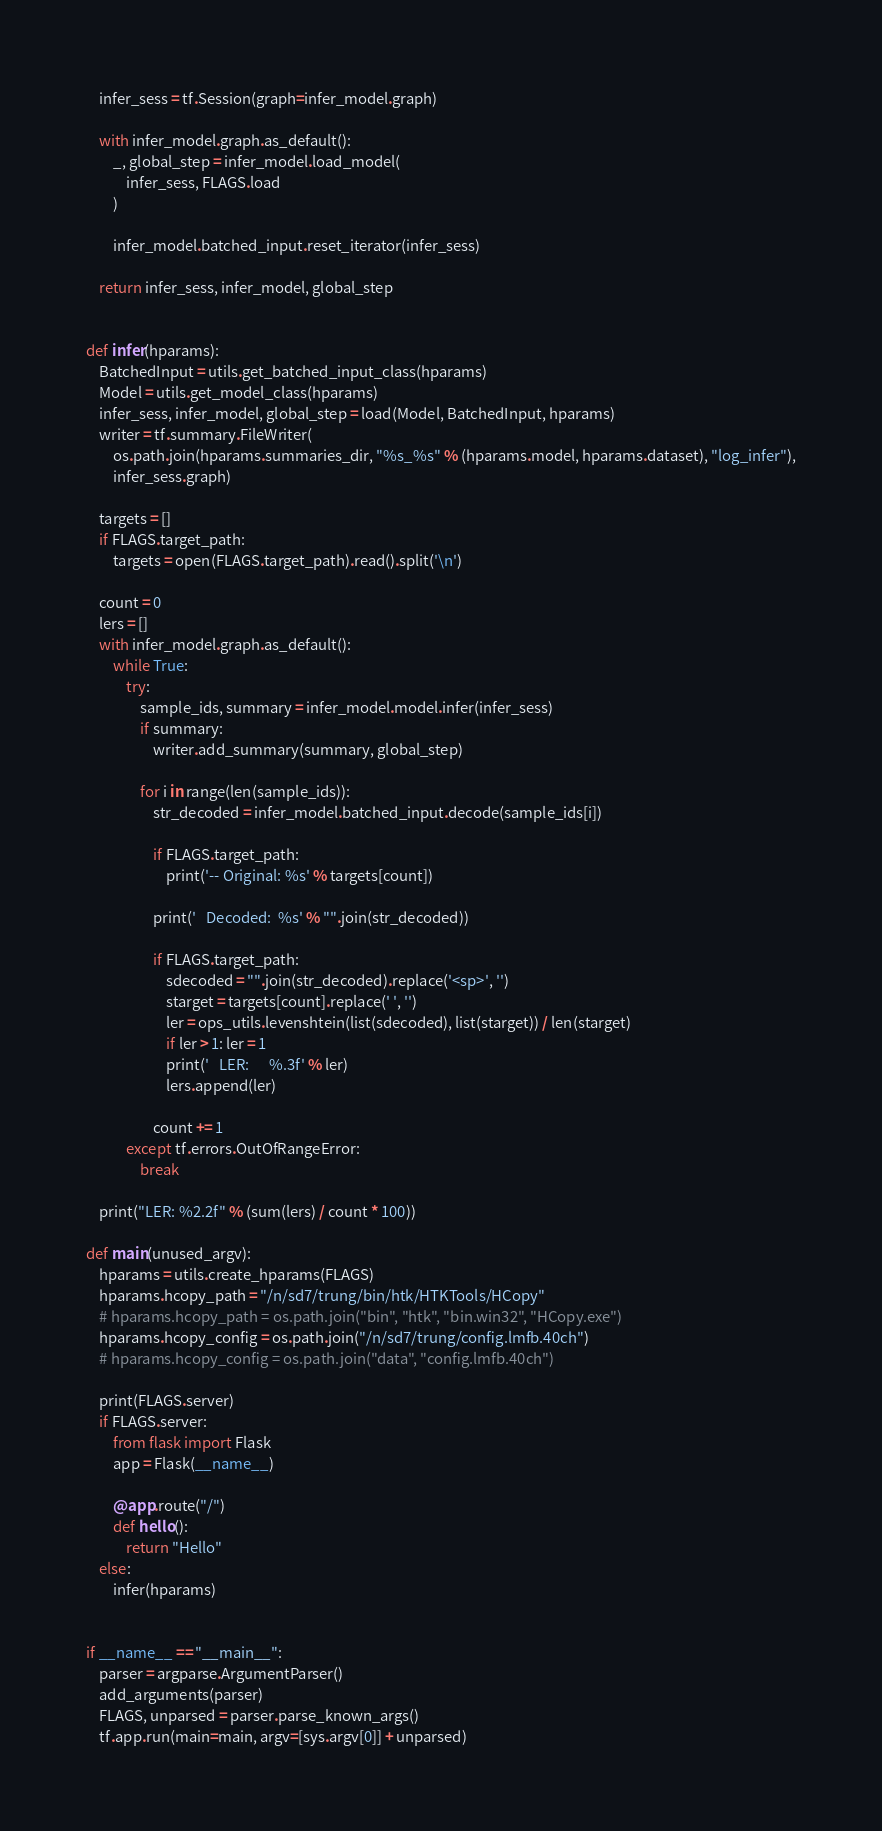Convert code to text. <code><loc_0><loc_0><loc_500><loc_500><_Python_>    infer_sess = tf.Session(graph=infer_model.graph)

    with infer_model.graph.as_default():
        _, global_step = infer_model.load_model(
            infer_sess, FLAGS.load
        )

        infer_model.batched_input.reset_iterator(infer_sess)

    return infer_sess, infer_model, global_step


def infer(hparams):
    BatchedInput = utils.get_batched_input_class(hparams)
    Model = utils.get_model_class(hparams)
    infer_sess, infer_model, global_step = load(Model, BatchedInput, hparams)
    writer = tf.summary.FileWriter(
        os.path.join(hparams.summaries_dir, "%s_%s" % (hparams.model, hparams.dataset), "log_infer"),
        infer_sess.graph)

    targets = []
    if FLAGS.target_path:
        targets = open(FLAGS.target_path).read().split('\n')

    count = 0
    lers = []
    with infer_model.graph.as_default():
        while True:
            try:
                sample_ids, summary = infer_model.model.infer(infer_sess)
                if summary:
                    writer.add_summary(summary, global_step)

                for i in range(len(sample_ids)):
                    str_decoded = infer_model.batched_input.decode(sample_ids[i])

                    if FLAGS.target_path:
                        print('-- Original: %s' % targets[count])

                    print('   Decoded:  %s' % "".join(str_decoded))

                    if FLAGS.target_path:
                        sdecoded = "".join(str_decoded).replace('<sp>', '')
                        starget = targets[count].replace(' ', '')
                        ler = ops_utils.levenshtein(list(sdecoded), list(starget)) / len(starget)
                        if ler > 1: ler = 1
                        print('   LER:      %.3f' % ler)
                        lers.append(ler)

                    count += 1
            except tf.errors.OutOfRangeError:
                break

    print("LER: %2.2f" % (sum(lers) / count * 100))

def main(unused_argv):
    hparams = utils.create_hparams(FLAGS)
    hparams.hcopy_path = "/n/sd7/trung/bin/htk/HTKTools/HCopy"
    # hparams.hcopy_path = os.path.join("bin", "htk", "bin.win32", "HCopy.exe")
    hparams.hcopy_config = os.path.join("/n/sd7/trung/config.lmfb.40ch")
    # hparams.hcopy_config = os.path.join("data", "config.lmfb.40ch")

    print(FLAGS.server)
    if FLAGS.server:
        from flask import Flask
        app = Flask(__name__)

        @app.route("/")
        def hello():
            return "Hello"
    else:
        infer(hparams)


if __name__ == "__main__":
    parser = argparse.ArgumentParser()
    add_arguments(parser)
    FLAGS, unparsed = parser.parse_known_args()
    tf.app.run(main=main, argv=[sys.argv[0]] + unparsed)
</code> 